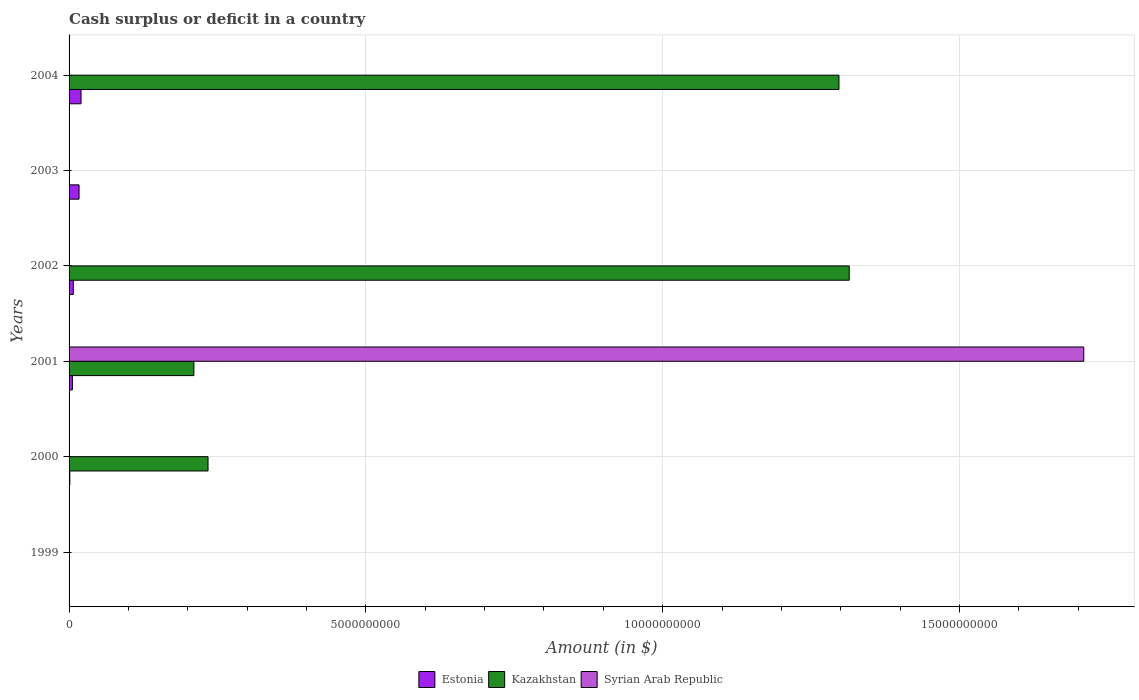How many different coloured bars are there?
Keep it short and to the point. 3. Are the number of bars per tick equal to the number of legend labels?
Ensure brevity in your answer.  No. Are the number of bars on each tick of the Y-axis equal?
Make the answer very short. No. How many bars are there on the 3rd tick from the top?
Your answer should be very brief. 2. What is the amount of cash surplus or deficit in Syrian Arab Republic in 2001?
Your answer should be very brief. 1.71e+1. Across all years, what is the maximum amount of cash surplus or deficit in Kazakhstan?
Offer a very short reply. 1.31e+1. What is the total amount of cash surplus or deficit in Estonia in the graph?
Keep it short and to the point. 5.10e+08. What is the difference between the amount of cash surplus or deficit in Estonia in 2001 and that in 2004?
Ensure brevity in your answer.  -1.45e+08. What is the average amount of cash surplus or deficit in Estonia per year?
Offer a very short reply. 8.49e+07. In the year 2004, what is the difference between the amount of cash surplus or deficit in Kazakhstan and amount of cash surplus or deficit in Estonia?
Make the answer very short. 1.28e+1. What is the ratio of the amount of cash surplus or deficit in Estonia in 2001 to that in 2004?
Give a very brief answer. 0.28. Is the amount of cash surplus or deficit in Estonia in 2000 less than that in 2001?
Ensure brevity in your answer.  Yes. Is the difference between the amount of cash surplus or deficit in Kazakhstan in 2001 and 2002 greater than the difference between the amount of cash surplus or deficit in Estonia in 2001 and 2002?
Offer a very short reply. No. What is the difference between the highest and the second highest amount of cash surplus or deficit in Kazakhstan?
Make the answer very short. 1.73e+08. What is the difference between the highest and the lowest amount of cash surplus or deficit in Syrian Arab Republic?
Your response must be concise. 1.71e+1. In how many years, is the amount of cash surplus or deficit in Syrian Arab Republic greater than the average amount of cash surplus or deficit in Syrian Arab Republic taken over all years?
Your answer should be compact. 1. How many bars are there?
Make the answer very short. 10. Are all the bars in the graph horizontal?
Provide a short and direct response. Yes. What is the difference between two consecutive major ticks on the X-axis?
Your answer should be compact. 5.00e+09. Are the values on the major ticks of X-axis written in scientific E-notation?
Ensure brevity in your answer.  No. Does the graph contain grids?
Provide a succinct answer. Yes. What is the title of the graph?
Your answer should be very brief. Cash surplus or deficit in a country. Does "Heavily indebted poor countries" appear as one of the legend labels in the graph?
Provide a short and direct response. No. What is the label or title of the X-axis?
Your answer should be very brief. Amount (in $). What is the Amount (in $) of Estonia in 1999?
Offer a very short reply. 0. What is the Amount (in $) in Kazakhstan in 1999?
Provide a succinct answer. 0. What is the Amount (in $) in Estonia in 2000?
Give a very brief answer. 1.23e+07. What is the Amount (in $) of Kazakhstan in 2000?
Provide a short and direct response. 2.34e+09. What is the Amount (in $) in Estonia in 2001?
Keep it short and to the point. 5.61e+07. What is the Amount (in $) in Kazakhstan in 2001?
Provide a succinct answer. 2.10e+09. What is the Amount (in $) of Syrian Arab Republic in 2001?
Your response must be concise. 1.71e+1. What is the Amount (in $) of Estonia in 2002?
Provide a short and direct response. 7.14e+07. What is the Amount (in $) of Kazakhstan in 2002?
Offer a very short reply. 1.31e+1. What is the Amount (in $) in Syrian Arab Republic in 2002?
Provide a succinct answer. 0. What is the Amount (in $) in Estonia in 2003?
Your answer should be compact. 1.68e+08. What is the Amount (in $) of Syrian Arab Republic in 2003?
Your response must be concise. 0. What is the Amount (in $) in Estonia in 2004?
Your answer should be very brief. 2.01e+08. What is the Amount (in $) of Kazakhstan in 2004?
Your answer should be compact. 1.30e+1. Across all years, what is the maximum Amount (in $) in Estonia?
Your answer should be very brief. 2.01e+08. Across all years, what is the maximum Amount (in $) in Kazakhstan?
Give a very brief answer. 1.31e+1. Across all years, what is the maximum Amount (in $) of Syrian Arab Republic?
Provide a succinct answer. 1.71e+1. Across all years, what is the minimum Amount (in $) in Syrian Arab Republic?
Provide a short and direct response. 0. What is the total Amount (in $) in Estonia in the graph?
Offer a terse response. 5.10e+08. What is the total Amount (in $) in Kazakhstan in the graph?
Offer a very short reply. 3.06e+1. What is the total Amount (in $) in Syrian Arab Republic in the graph?
Make the answer very short. 1.71e+1. What is the difference between the Amount (in $) of Estonia in 2000 and that in 2001?
Offer a very short reply. -4.38e+07. What is the difference between the Amount (in $) of Kazakhstan in 2000 and that in 2001?
Your answer should be very brief. 2.38e+08. What is the difference between the Amount (in $) in Estonia in 2000 and that in 2002?
Your answer should be compact. -5.91e+07. What is the difference between the Amount (in $) of Kazakhstan in 2000 and that in 2002?
Your answer should be very brief. -1.08e+1. What is the difference between the Amount (in $) of Estonia in 2000 and that in 2003?
Provide a short and direct response. -1.56e+08. What is the difference between the Amount (in $) in Estonia in 2000 and that in 2004?
Offer a terse response. -1.89e+08. What is the difference between the Amount (in $) of Kazakhstan in 2000 and that in 2004?
Provide a short and direct response. -1.06e+1. What is the difference between the Amount (in $) of Estonia in 2001 and that in 2002?
Ensure brevity in your answer.  -1.53e+07. What is the difference between the Amount (in $) in Kazakhstan in 2001 and that in 2002?
Provide a succinct answer. -1.10e+1. What is the difference between the Amount (in $) of Estonia in 2001 and that in 2003?
Keep it short and to the point. -1.12e+08. What is the difference between the Amount (in $) in Estonia in 2001 and that in 2004?
Keep it short and to the point. -1.45e+08. What is the difference between the Amount (in $) in Kazakhstan in 2001 and that in 2004?
Provide a short and direct response. -1.09e+1. What is the difference between the Amount (in $) of Estonia in 2002 and that in 2003?
Offer a terse response. -9.69e+07. What is the difference between the Amount (in $) in Estonia in 2002 and that in 2004?
Your answer should be compact. -1.30e+08. What is the difference between the Amount (in $) in Kazakhstan in 2002 and that in 2004?
Provide a short and direct response. 1.73e+08. What is the difference between the Amount (in $) of Estonia in 2003 and that in 2004?
Ensure brevity in your answer.  -3.31e+07. What is the difference between the Amount (in $) of Estonia in 2000 and the Amount (in $) of Kazakhstan in 2001?
Keep it short and to the point. -2.09e+09. What is the difference between the Amount (in $) of Estonia in 2000 and the Amount (in $) of Syrian Arab Republic in 2001?
Give a very brief answer. -1.71e+1. What is the difference between the Amount (in $) of Kazakhstan in 2000 and the Amount (in $) of Syrian Arab Republic in 2001?
Your response must be concise. -1.48e+1. What is the difference between the Amount (in $) of Estonia in 2000 and the Amount (in $) of Kazakhstan in 2002?
Your answer should be very brief. -1.31e+1. What is the difference between the Amount (in $) of Estonia in 2000 and the Amount (in $) of Kazakhstan in 2004?
Ensure brevity in your answer.  -1.30e+1. What is the difference between the Amount (in $) in Estonia in 2001 and the Amount (in $) in Kazakhstan in 2002?
Offer a terse response. -1.31e+1. What is the difference between the Amount (in $) of Estonia in 2001 and the Amount (in $) of Kazakhstan in 2004?
Ensure brevity in your answer.  -1.29e+1. What is the difference between the Amount (in $) in Estonia in 2002 and the Amount (in $) in Kazakhstan in 2004?
Your response must be concise. -1.29e+1. What is the difference between the Amount (in $) in Estonia in 2003 and the Amount (in $) in Kazakhstan in 2004?
Keep it short and to the point. -1.28e+1. What is the average Amount (in $) of Estonia per year?
Your response must be concise. 8.49e+07. What is the average Amount (in $) of Kazakhstan per year?
Offer a terse response. 5.09e+09. What is the average Amount (in $) in Syrian Arab Republic per year?
Provide a succinct answer. 2.85e+09. In the year 2000, what is the difference between the Amount (in $) of Estonia and Amount (in $) of Kazakhstan?
Provide a short and direct response. -2.33e+09. In the year 2001, what is the difference between the Amount (in $) of Estonia and Amount (in $) of Kazakhstan?
Give a very brief answer. -2.05e+09. In the year 2001, what is the difference between the Amount (in $) of Estonia and Amount (in $) of Syrian Arab Republic?
Your answer should be very brief. -1.70e+1. In the year 2001, what is the difference between the Amount (in $) of Kazakhstan and Amount (in $) of Syrian Arab Republic?
Provide a succinct answer. -1.50e+1. In the year 2002, what is the difference between the Amount (in $) of Estonia and Amount (in $) of Kazakhstan?
Your response must be concise. -1.31e+1. In the year 2004, what is the difference between the Amount (in $) in Estonia and Amount (in $) in Kazakhstan?
Your response must be concise. -1.28e+1. What is the ratio of the Amount (in $) in Estonia in 2000 to that in 2001?
Provide a succinct answer. 0.22. What is the ratio of the Amount (in $) in Kazakhstan in 2000 to that in 2001?
Your answer should be very brief. 1.11. What is the ratio of the Amount (in $) of Estonia in 2000 to that in 2002?
Your response must be concise. 0.17. What is the ratio of the Amount (in $) in Kazakhstan in 2000 to that in 2002?
Offer a terse response. 0.18. What is the ratio of the Amount (in $) of Estonia in 2000 to that in 2003?
Keep it short and to the point. 0.07. What is the ratio of the Amount (in $) in Estonia in 2000 to that in 2004?
Ensure brevity in your answer.  0.06. What is the ratio of the Amount (in $) of Kazakhstan in 2000 to that in 2004?
Your response must be concise. 0.18. What is the ratio of the Amount (in $) of Estonia in 2001 to that in 2002?
Ensure brevity in your answer.  0.79. What is the ratio of the Amount (in $) in Kazakhstan in 2001 to that in 2002?
Make the answer very short. 0.16. What is the ratio of the Amount (in $) in Estonia in 2001 to that in 2003?
Keep it short and to the point. 0.33. What is the ratio of the Amount (in $) of Estonia in 2001 to that in 2004?
Offer a very short reply. 0.28. What is the ratio of the Amount (in $) in Kazakhstan in 2001 to that in 2004?
Make the answer very short. 0.16. What is the ratio of the Amount (in $) of Estonia in 2002 to that in 2003?
Offer a terse response. 0.42. What is the ratio of the Amount (in $) of Estonia in 2002 to that in 2004?
Offer a terse response. 0.35. What is the ratio of the Amount (in $) of Kazakhstan in 2002 to that in 2004?
Make the answer very short. 1.01. What is the ratio of the Amount (in $) in Estonia in 2003 to that in 2004?
Provide a short and direct response. 0.84. What is the difference between the highest and the second highest Amount (in $) of Estonia?
Offer a very short reply. 3.31e+07. What is the difference between the highest and the second highest Amount (in $) in Kazakhstan?
Offer a very short reply. 1.73e+08. What is the difference between the highest and the lowest Amount (in $) of Estonia?
Provide a short and direct response. 2.01e+08. What is the difference between the highest and the lowest Amount (in $) in Kazakhstan?
Your answer should be very brief. 1.31e+1. What is the difference between the highest and the lowest Amount (in $) of Syrian Arab Republic?
Provide a succinct answer. 1.71e+1. 